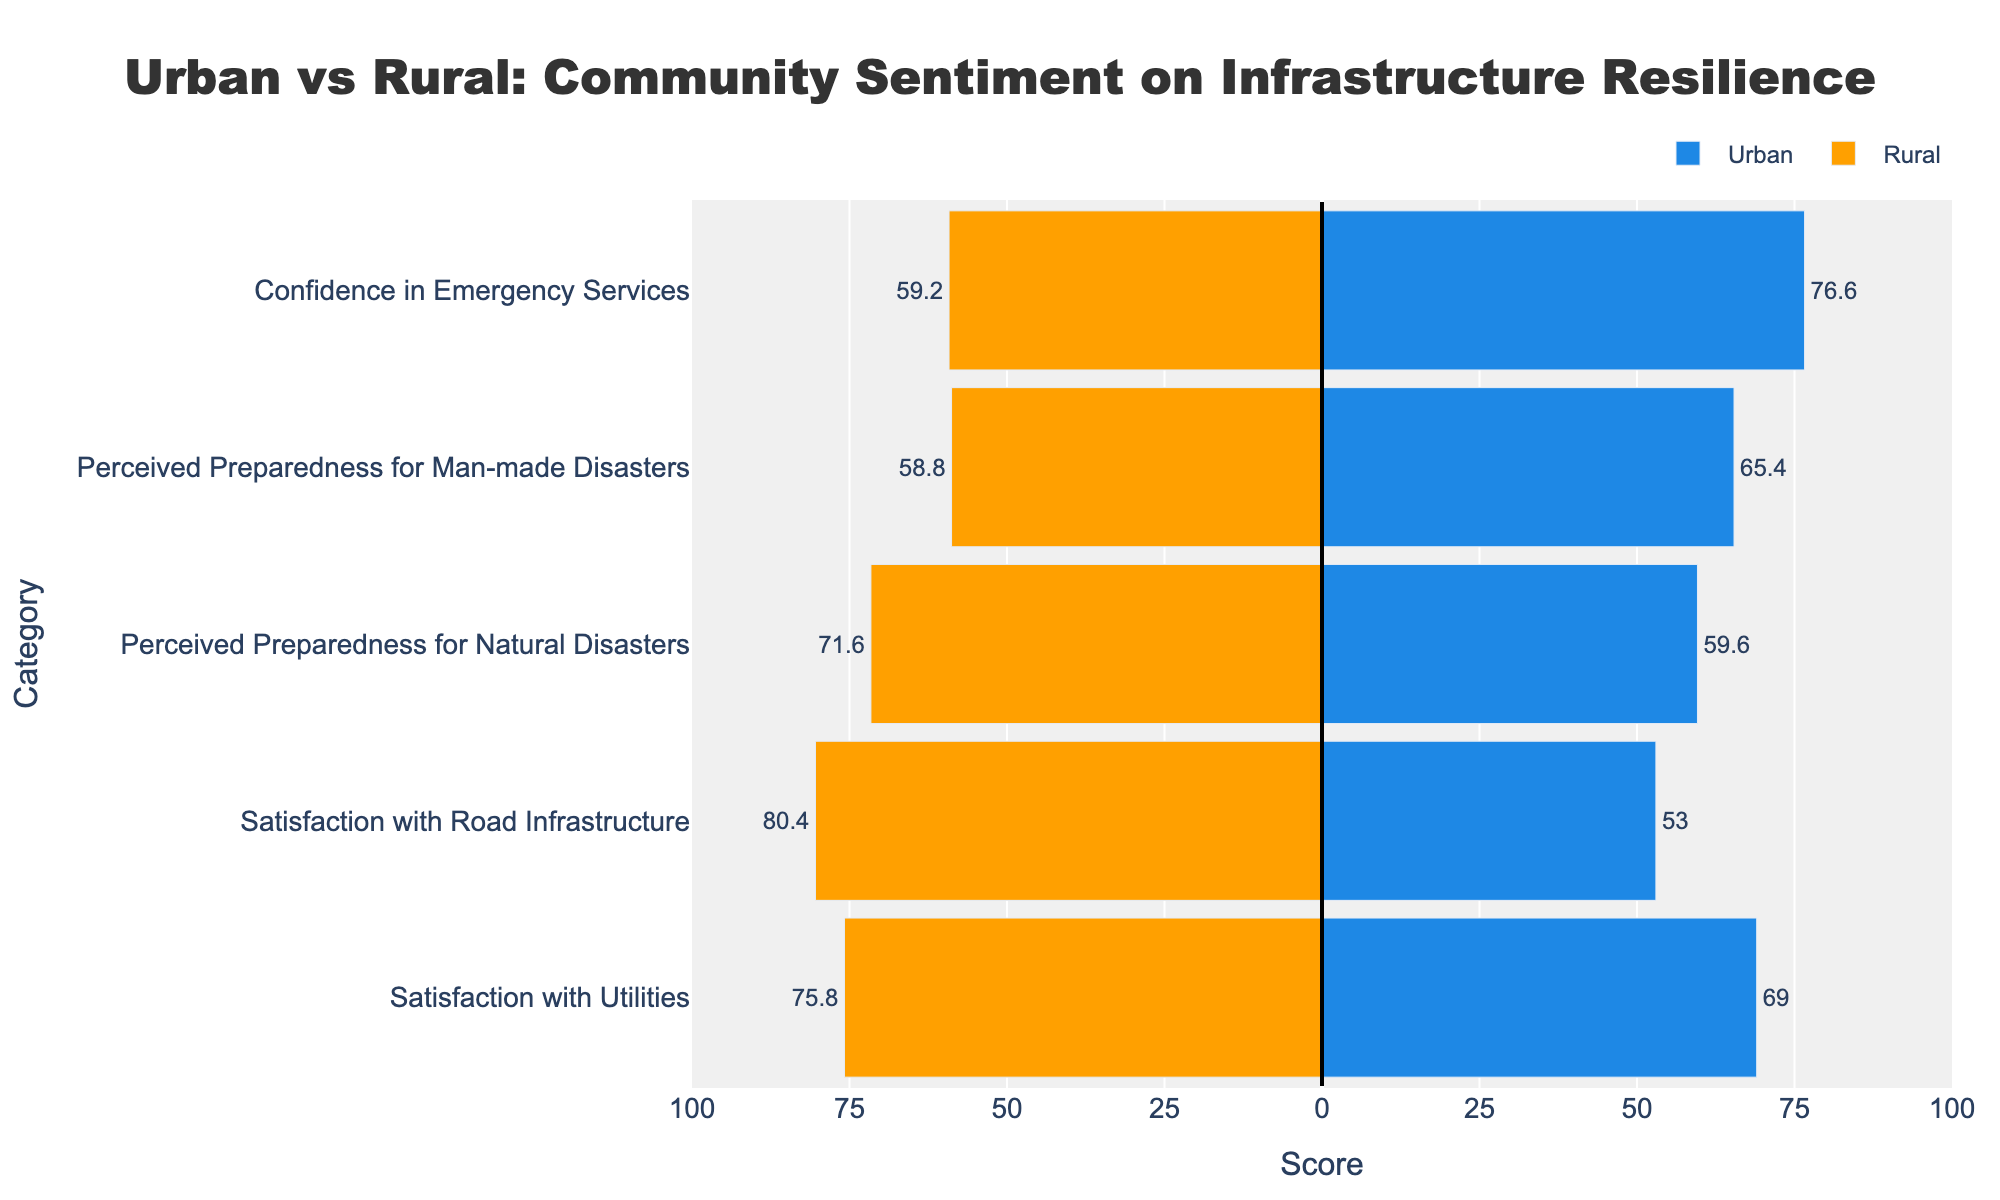What category shows the greatest difference in mean scores between urban and rural areas? Observing the lengths of the bars, we see that 'Satisfaction with Road Infrastructure' has the largest difference in score length between urban and rural areas, indicating different levels of satisfaction.
Answer: Satisfaction with Road Infrastructure Which area, urban or rural, demonstrates higher confidence in emergency services? The bar representing 'Confidence in Emergency Services' extends further to the right for urban areas, indicating a higher mean score.
Answer: Urban In which category do rural areas have their lowest average score? Looking at the negative bar lengths for rural areas, 'Confidence in Emergency Services' has the shortest extension to the left, indicating the lowest average score.
Answer: Confidence in Emergency Services By how much does the mean urban score for 'Perceived Preparedness for Natural Disasters' exceed the mean rural score for this category? Subtract the negative value of the rural score from the positive value of the urban score for 'Perceived Preparedness for Natural Disasters': 61 - (-70) = 131.
Answer: 131 Is 'Satisfaction with Utilities' higher on average in urban or rural areas? The positive bar for urban areas is shorter compared to the negative bar for rural areas in the 'Satisfaction with Utilities’ category, indicating higher satisfaction in rural areas.
Answer: Rural What is the mean score difference between urban and rural areas for 'Perceived Preparedness for Man-made Disasters'? Subtract the absolute value of the rural score from the urban score for 'Perceived Preparedness for Man-made Disasters': 65 - 59 = 6.
Answer: 6 Compare the urban and rural levels of 'Confidence in Emergency Services'. Which one demonstrates a higher perception of community preparedness for natural disasters? By observing the bar lengths, urban areas have a longer positive bar than the rural negative bar for 'Confidence in Emergency Services', indicating higher perception.
Answer: Urban 